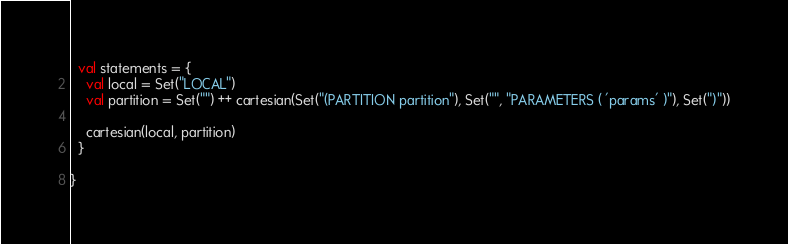<code> <loc_0><loc_0><loc_500><loc_500><_Scala_>  val statements = {
    val local = Set("LOCAL")
    val partition = Set("") ++ cartesian(Set("(PARTITION partition"), Set("", "PARAMETERS ( 'params' )"), Set(")"))

    cartesian(local, partition)
  }

}</code> 